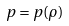<formula> <loc_0><loc_0><loc_500><loc_500>p = p ( \rho )</formula> 